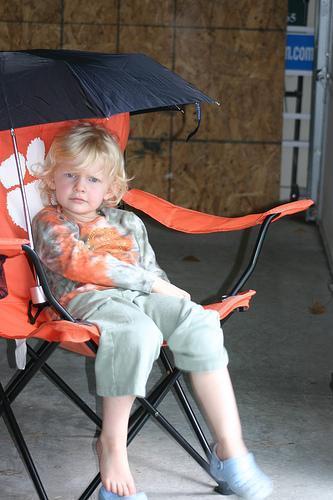How many people are pictured?
Give a very brief answer. 1. 